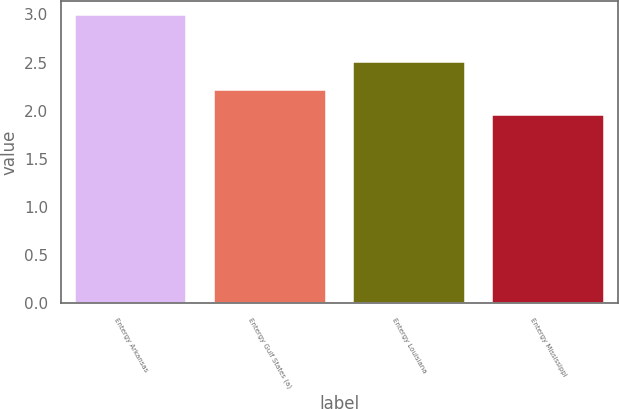Convert chart. <chart><loc_0><loc_0><loc_500><loc_500><bar_chart><fcel>Entergy Arkansas<fcel>Entergy Gulf States (a)<fcel>Entergy Louisiana<fcel>Entergy Mississippi<nl><fcel>2.99<fcel>2.21<fcel>2.51<fcel>1.96<nl></chart> 